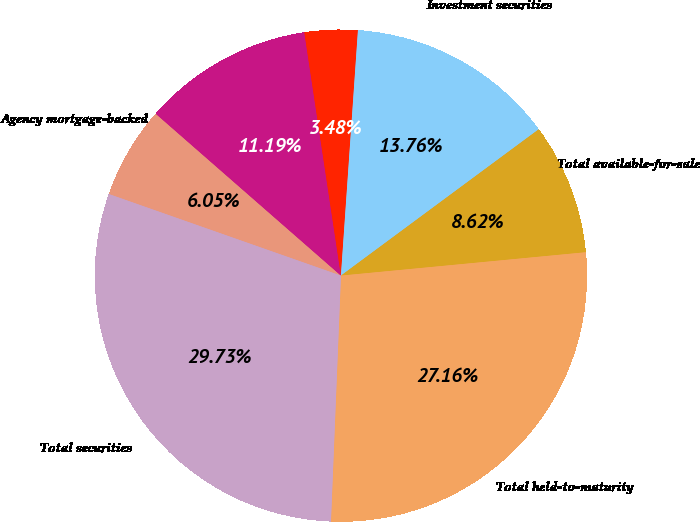Convert chart to OTSL. <chart><loc_0><loc_0><loc_500><loc_500><pie_chart><fcel>Agency mortgage-backed<fcel>Non-agency CMOs<fcel>Total residential<fcel>Investment securities<fcel>Total available-for-sale<fcel>Total held-to-maturity<fcel>Total securities<nl><fcel>6.05%<fcel>11.19%<fcel>3.48%<fcel>13.76%<fcel>8.62%<fcel>27.16%<fcel>29.73%<nl></chart> 